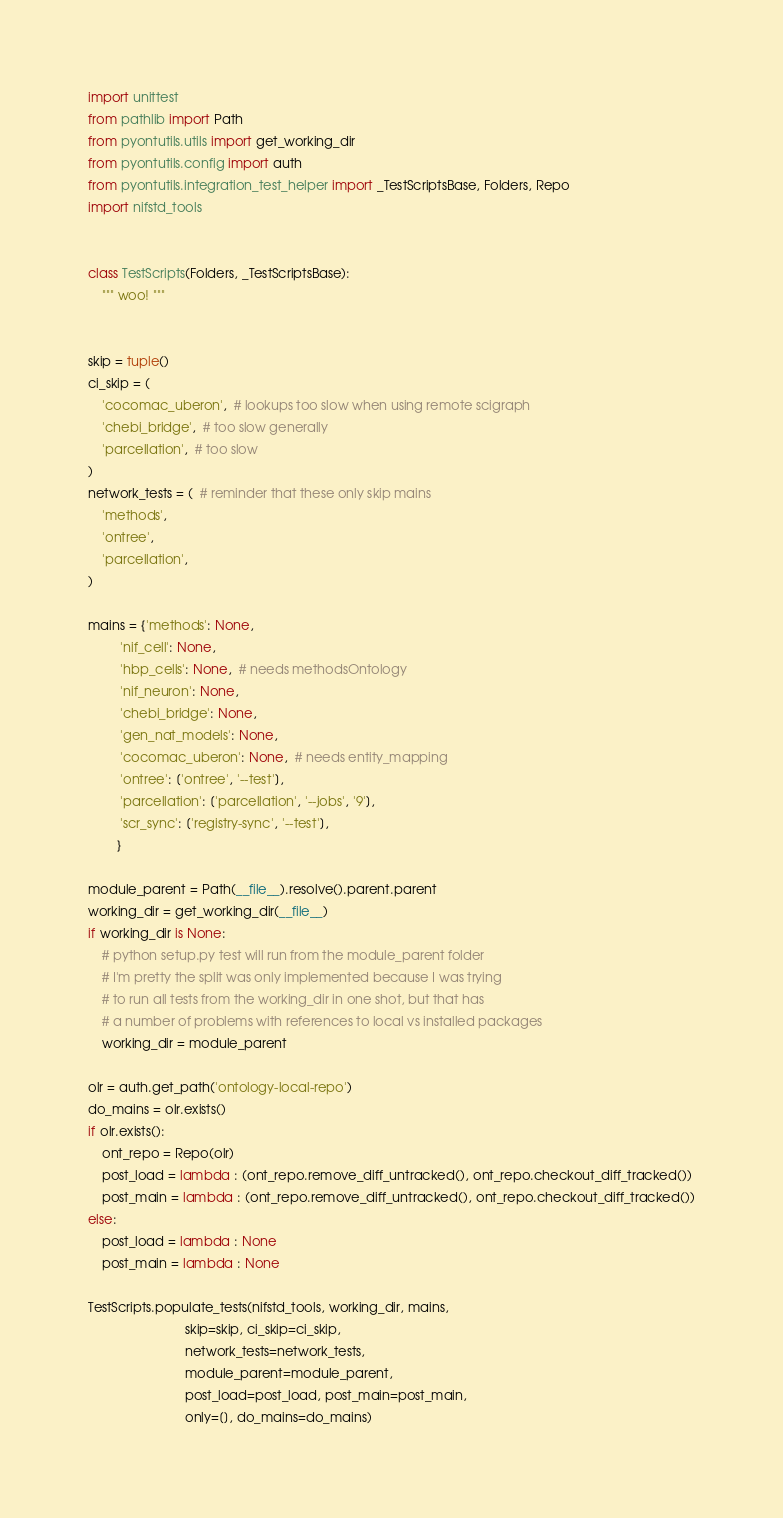Convert code to text. <code><loc_0><loc_0><loc_500><loc_500><_Python_>import unittest
from pathlib import Path
from pyontutils.utils import get_working_dir
from pyontutils.config import auth
from pyontutils.integration_test_helper import _TestScriptsBase, Folders, Repo
import nifstd_tools


class TestScripts(Folders, _TestScriptsBase):
    """ woo! """


skip = tuple()
ci_skip = (
    'cocomac_uberon',  # lookups too slow when using remote scigraph
    'chebi_bridge',  # too slow generally
    'parcellation',  # too slow
)
network_tests = (  # reminder that these only skip mains
    'methods',
    'ontree',
    'parcellation',
)

mains = {'methods': None,
         'nif_cell': None,
         'hbp_cells': None,  # needs methodsOntology
         'nif_neuron': None,
         'chebi_bridge': None,
         'gen_nat_models': None,
         'cocomac_uberon': None,  # needs entity_mapping
         'ontree': ['ontree', '--test'],
         'parcellation': ['parcellation', '--jobs', '9'],
         'scr_sync': ['registry-sync', '--test'],
        }

module_parent = Path(__file__).resolve().parent.parent
working_dir = get_working_dir(__file__)
if working_dir is None:
    # python setup.py test will run from the module_parent folder
    # I'm pretty the split was only implemented because I was trying
    # to run all tests from the working_dir in one shot, but that has
    # a number of problems with references to local vs installed packages
    working_dir = module_parent

olr = auth.get_path('ontology-local-repo')
do_mains = olr.exists()
if olr.exists():
    ont_repo = Repo(olr)
    post_load = lambda : (ont_repo.remove_diff_untracked(), ont_repo.checkout_diff_tracked())
    post_main = lambda : (ont_repo.remove_diff_untracked(), ont_repo.checkout_diff_tracked())
else:
    post_load = lambda : None
    post_main = lambda : None

TestScripts.populate_tests(nifstd_tools, working_dir, mains,
                           skip=skip, ci_skip=ci_skip,
                           network_tests=network_tests,
                           module_parent=module_parent,
                           post_load=post_load, post_main=post_main,
                           only=[], do_mains=do_mains)
</code> 